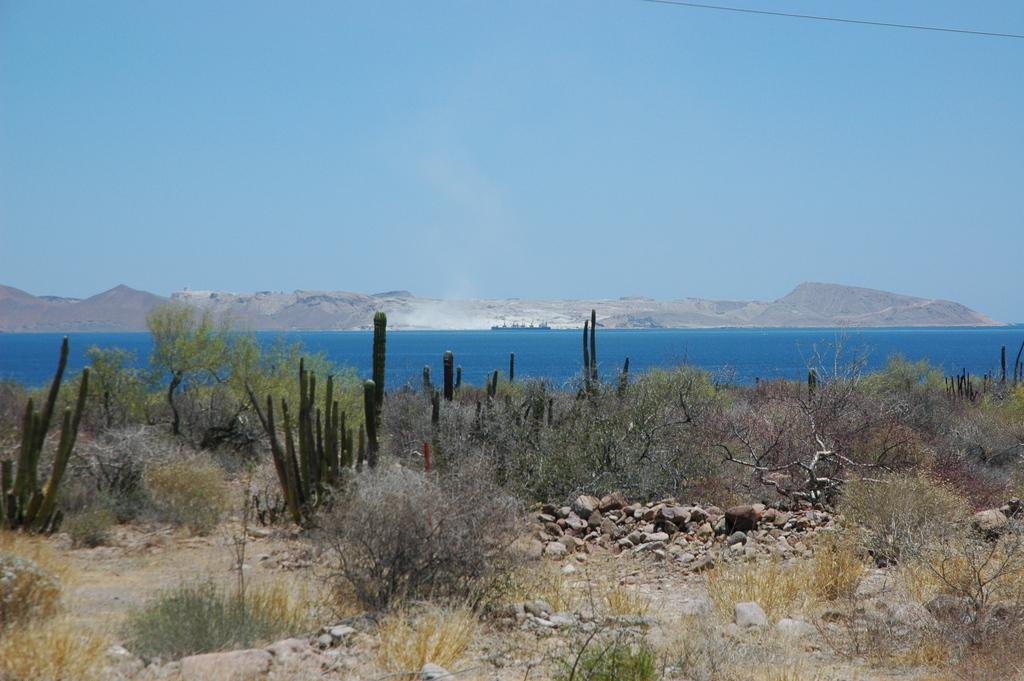What type of natural elements can be seen in the image? Plants, rocks, and water are visible in the image. What type of terrain is visible in the background of the image? There are mountains in the background of the image. What thought is the wind having in the image? There is no wind present in the image, and therefore no thoughts can be attributed to it. 